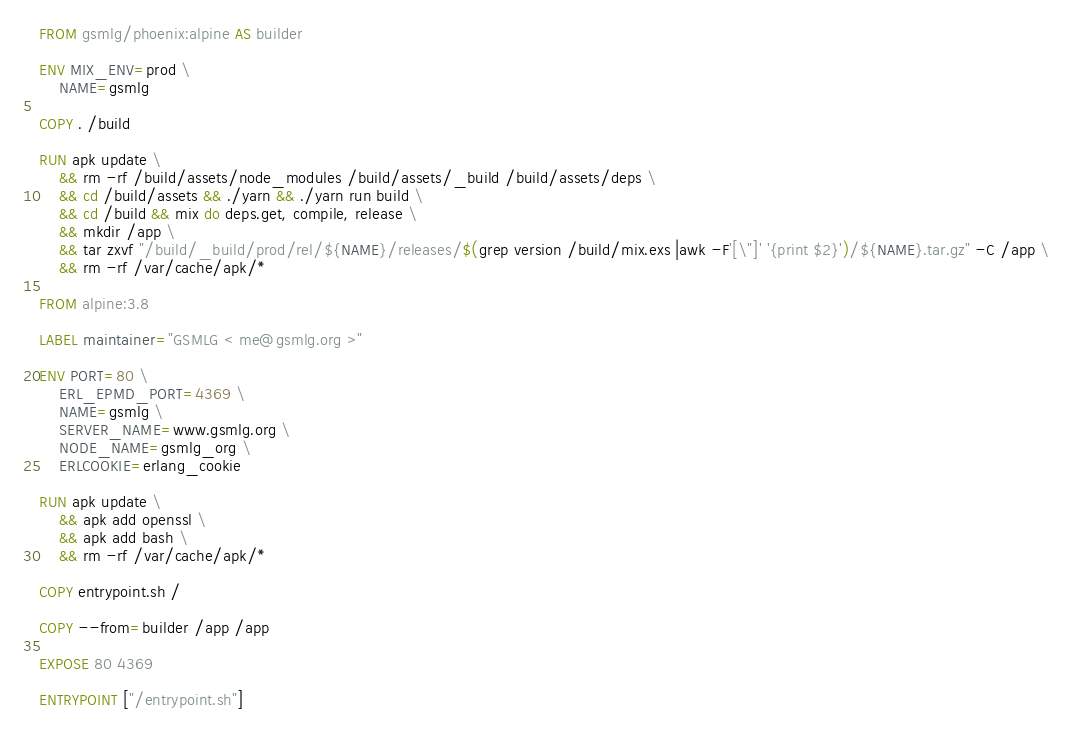Convert code to text. <code><loc_0><loc_0><loc_500><loc_500><_Dockerfile_>FROM gsmlg/phoenix:alpine AS builder

ENV MIX_ENV=prod \
    NAME=gsmlg

COPY . /build

RUN apk update \
    && rm -rf /build/assets/node_modules /build/assets/_build /build/assets/deps \
    && cd /build/assets && ./yarn && ./yarn run build \
    && cd /build && mix do deps.get, compile, release \
    && mkdir /app \
    && tar zxvf "/build/_build/prod/rel/${NAME}/releases/$(grep version /build/mix.exs |awk -F'[\"]' '{print $2}')/${NAME}.tar.gz" -C /app \
    && rm -rf /var/cache/apk/*

FROM alpine:3.8

LABEL maintainer="GSMLG < me@gsmlg.org >"

ENV PORT=80 \
    ERL_EPMD_PORT=4369 \
    NAME=gsmlg \
    SERVER_NAME=www.gsmlg.org \
    NODE_NAME=gsmlg_org \
    ERLCOOKIE=erlang_cookie

RUN apk update \
    && apk add openssl \
    && apk add bash \
    && rm -rf /var/cache/apk/*

COPY entrypoint.sh /

COPY --from=builder /app /app

EXPOSE 80 4369

ENTRYPOINT ["/entrypoint.sh"]
</code> 